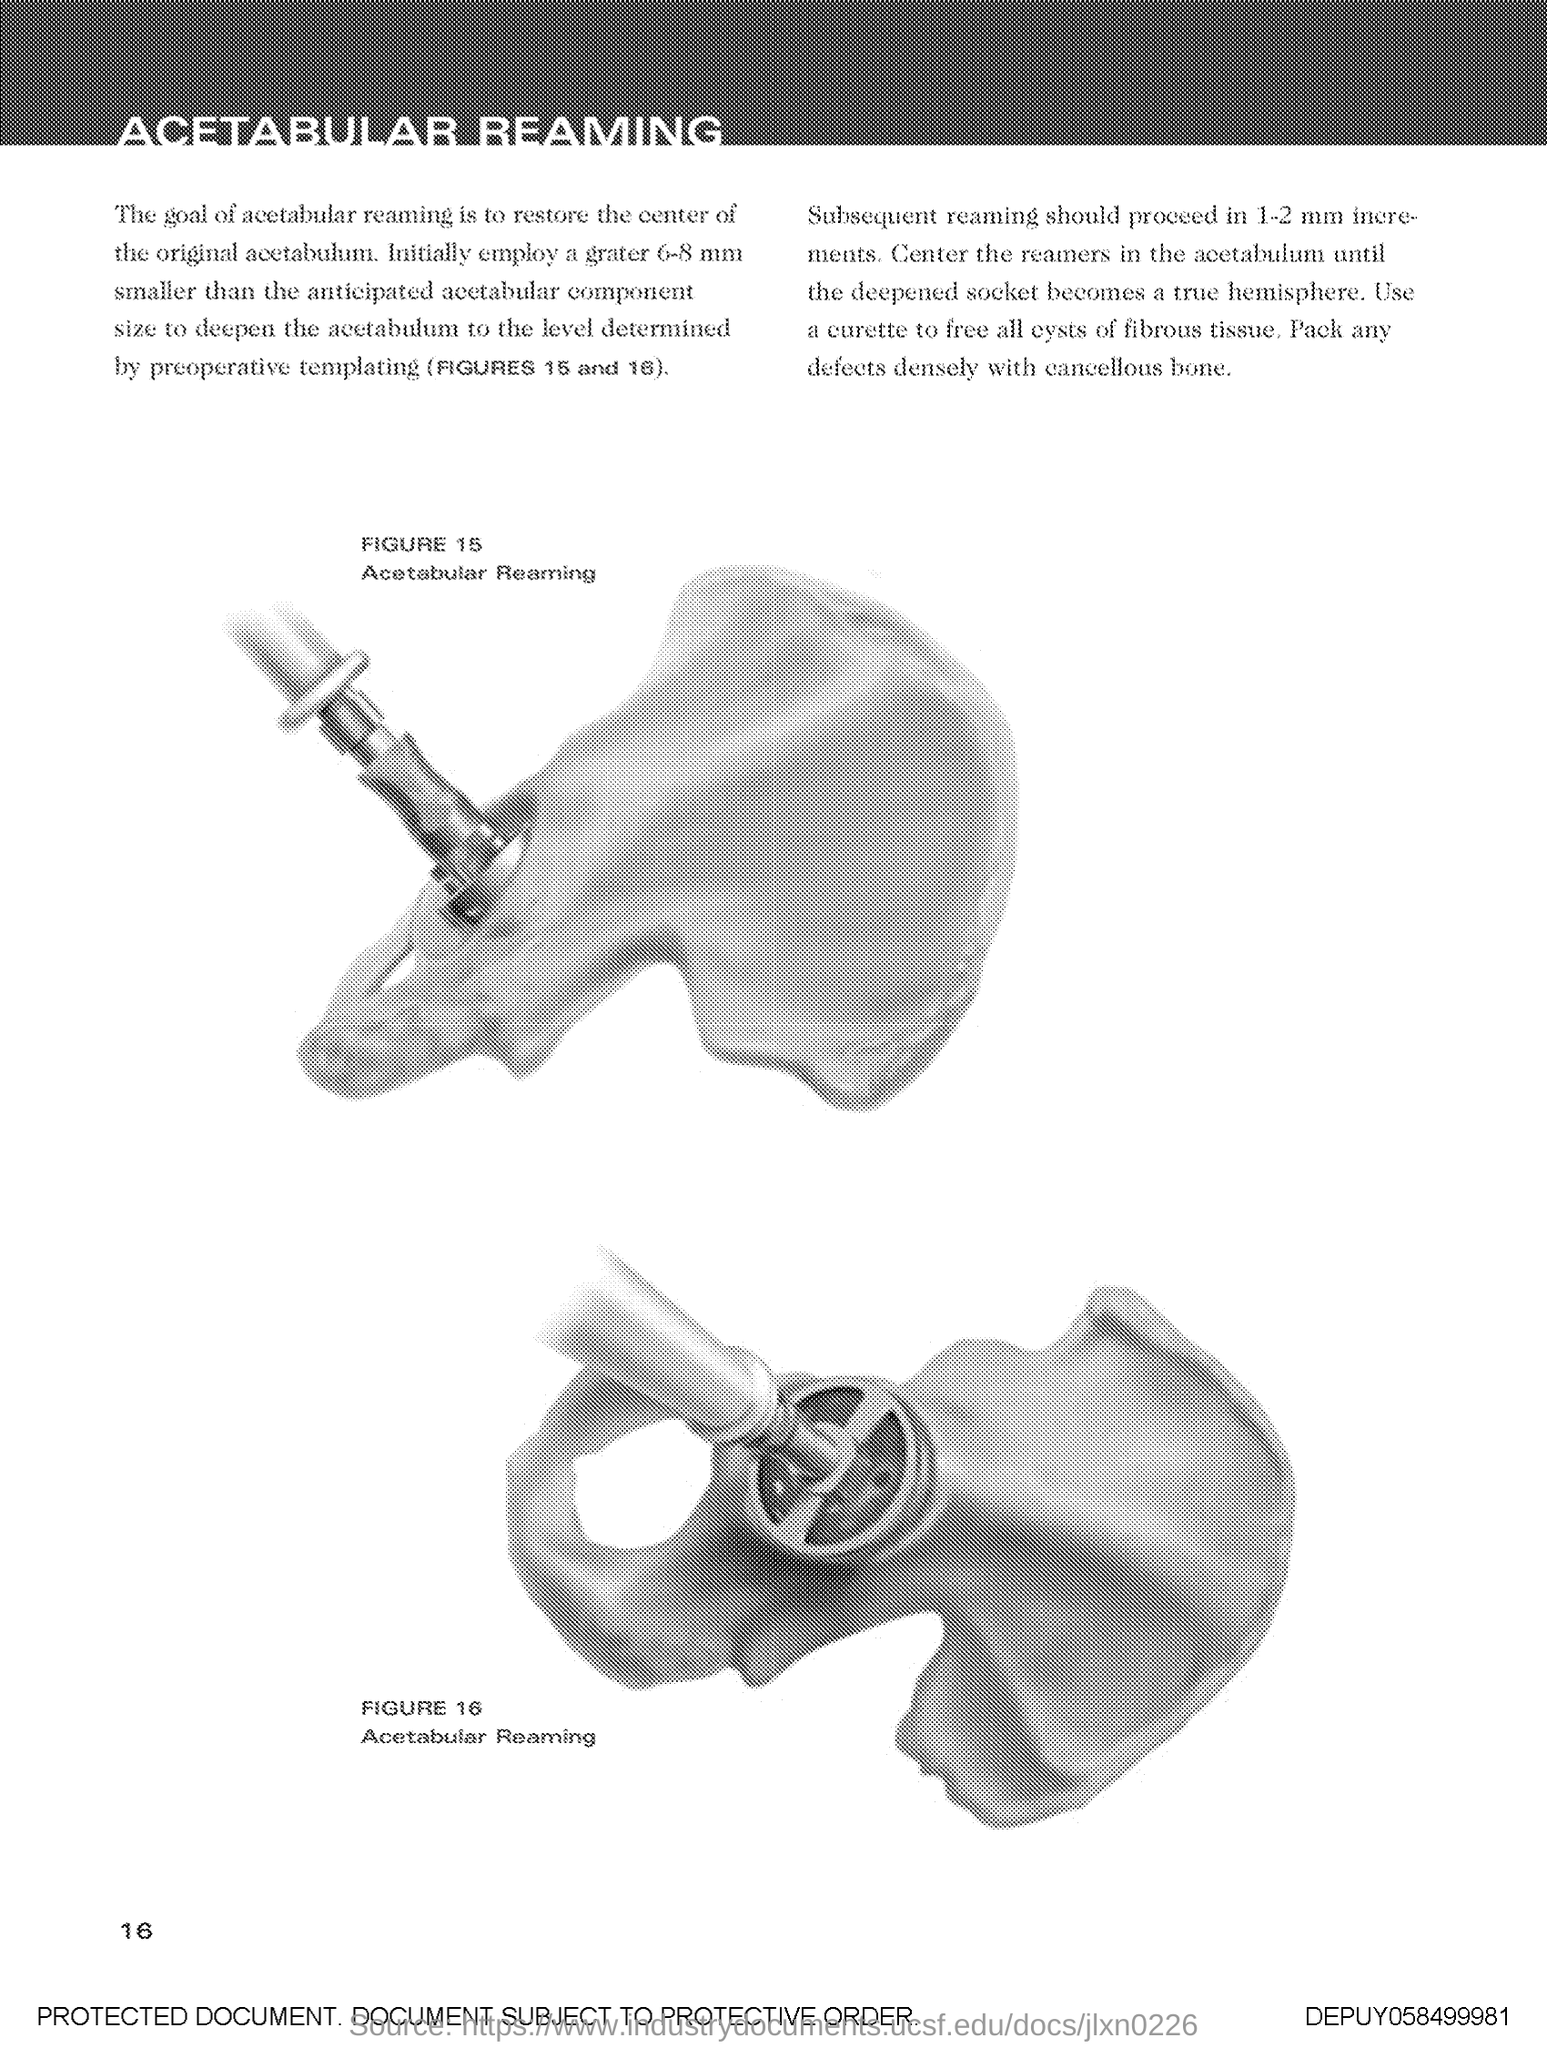What is the number at bottom-left side of the page?
Keep it short and to the point. 16. 